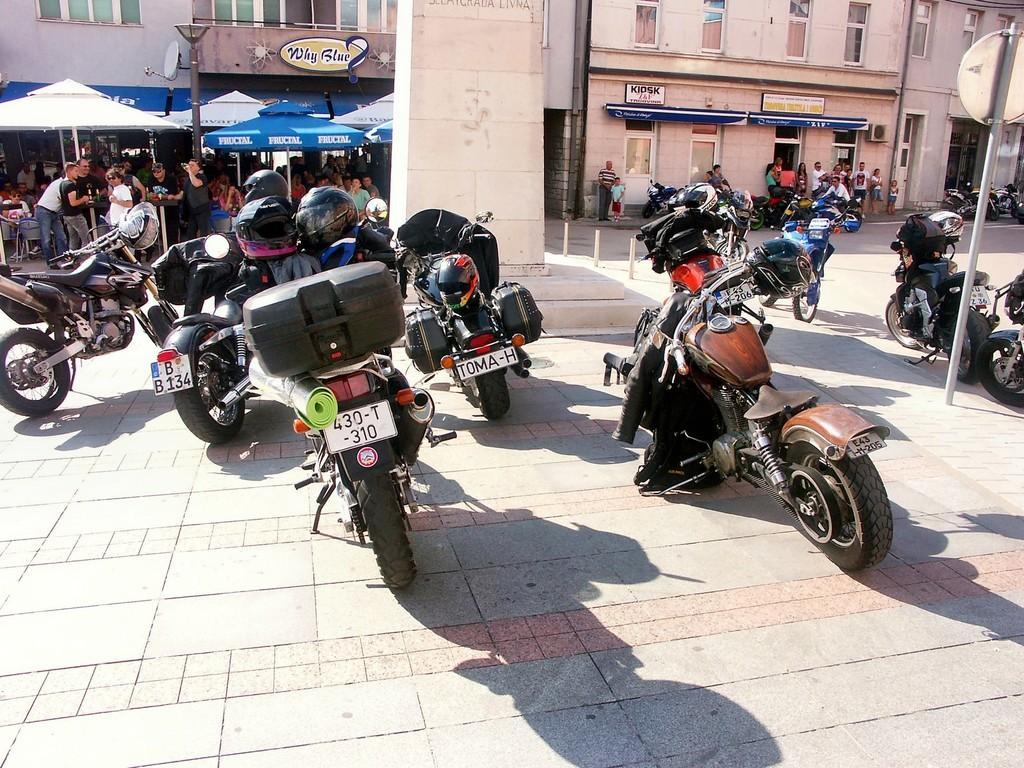How would you summarize this image in a sentence or two? In this image we can see the buildings, barrier rods, light pole, sign board pole and also the tents for shelter. We can also see the people, vehicles, road and also the path. 